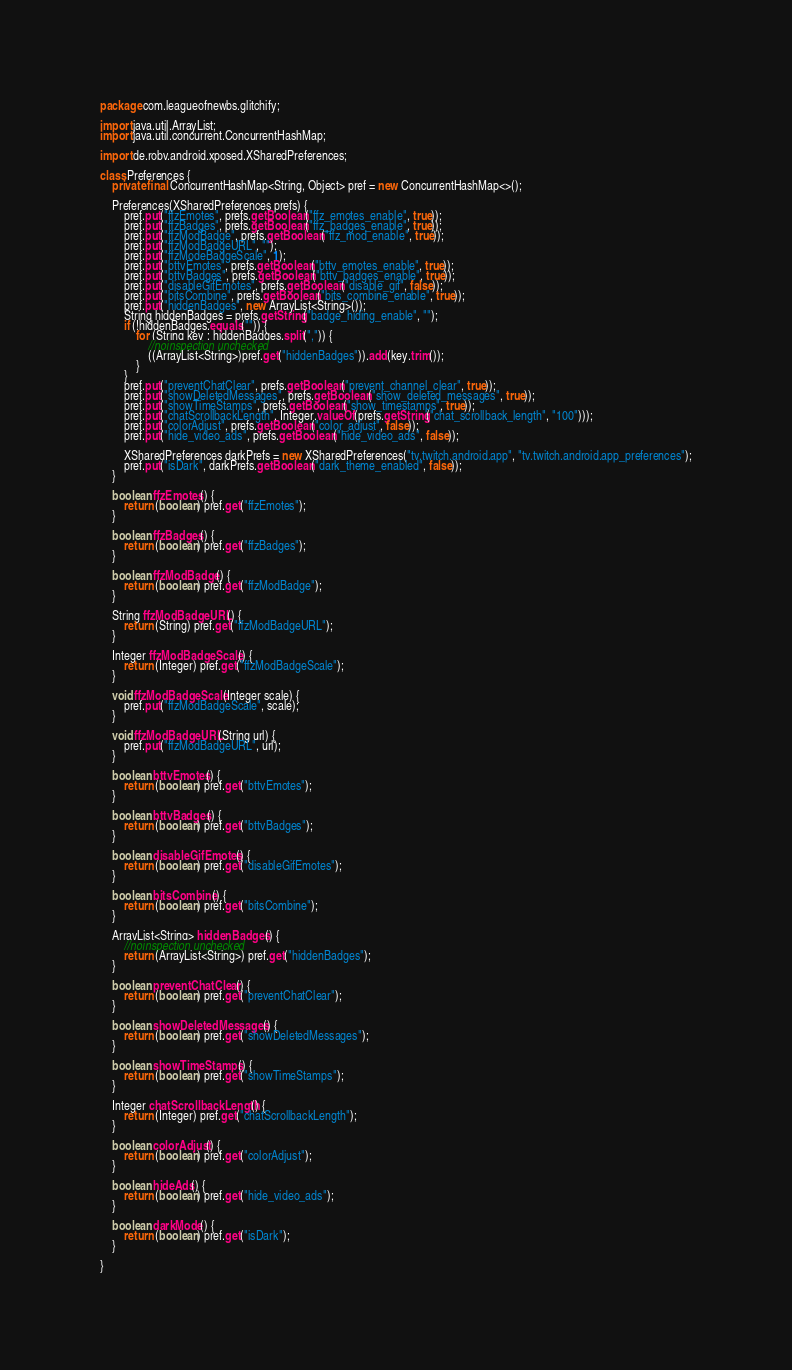Convert code to text. <code><loc_0><loc_0><loc_500><loc_500><_Java_>package com.leagueofnewbs.glitchify;

import java.util.ArrayList;
import java.util.concurrent.ConcurrentHashMap;

import de.robv.android.xposed.XSharedPreferences;

class Preferences {
    private final ConcurrentHashMap<String, Object> pref = new ConcurrentHashMap<>();

    Preferences(XSharedPreferences prefs) {
        pref.put("ffzEmotes", prefs.getBoolean("ffz_emotes_enable", true));
        pref.put("ffzBadges", prefs.getBoolean("ffz_badges_enable", true));
        pref.put("ffzModBadge", prefs.getBoolean("ffz_mod_enable", true));
        pref.put("ffzModBadgeURL", "");
        pref.put("ffzModeBadgeScale", 1);
        pref.put("bttvEmotes", prefs.getBoolean("bttv_emotes_enable", true));
        pref.put("bttvBadges", prefs.getBoolean("bttv_badges_enable", true));
        pref.put("disableGifEmotes", prefs.getBoolean("disable_gif", false));
        pref.put("bitsCombine", prefs.getBoolean("bits_combine_enable", true));
        pref.put("hiddenBadges", new ArrayList<String>());
        String hiddenBadges = prefs.getString("badge_hiding_enable", "");
        if (!hiddenBadges.equals("")) {
            for (String key : hiddenBadges.split(",")) {
                //noinspection unchecked
                ((ArrayList<String>)pref.get("hiddenBadges")).add(key.trim());
            }
        }
        pref.put("preventChatClear", prefs.getBoolean("prevent_channel_clear", true));
        pref.put("showDeletedMessages", prefs.getBoolean("show_deleted_messages", true));
        pref.put("showTimeStamps", prefs.getBoolean("show_timestamps", true));
        pref.put("chatScrollbackLength", Integer.valueOf(prefs.getString("chat_scrollback_length", "100")));
        pref.put("colorAdjust", prefs.getBoolean("color_adjust", false));
        pref.put("hide_video_ads", prefs.getBoolean("hide_video_ads", false));

        XSharedPreferences darkPrefs = new XSharedPreferences("tv.twitch.android.app", "tv.twitch.android.app_preferences");
        pref.put("isDark", darkPrefs.getBoolean("dark_theme_enabled", false));
    }

    boolean ffzEmotes() {
        return (boolean) pref.get("ffzEmotes");
    }

    boolean ffzBadges() {
        return (boolean) pref.get("ffzBadges");
    }

    boolean ffzModBadge() {
        return (boolean) pref.get("ffzModBadge");
    }

    String ffzModBadgeURL() {
        return (String) pref.get("ffzModBadgeURL");
    }

    Integer ffzModBadgeScale() {
        return (Integer) pref.get("ffzModBadgeScale");
    }

    void ffzModBadgeScale(Integer scale) {
        pref.put("ffzModBadgeScale", scale);
    }

    void ffzModBadgeURL(String url) {
        pref.put("ffzModBadgeURL", url);
    }

    boolean bttvEmotes() {
        return (boolean) pref.get("bttvEmotes");
    }

    boolean bttvBadges() {
        return (boolean) pref.get("bttvBadges");
    }

    boolean disableGifEmotes() {
        return (boolean) pref.get("disableGifEmotes");
    }

    boolean bitsCombine() {
        return (boolean) pref.get("bitsCombine");
    }

    ArrayList<String> hiddenBadges() {
        //noinspection unchecked
        return (ArrayList<String>) pref.get("hiddenBadges");
    }

    boolean preventChatClear() {
        return (boolean) pref.get("preventChatClear");
    }

    boolean showDeletedMessages() {
        return (boolean) pref.get("showDeletedMessages");
    }

    boolean showTimeStamps() {
        return (boolean) pref.get("showTimeStamps");
    }

    Integer chatScrollbackLength() {
        return (Integer) pref.get("chatScrollbackLength");
    }

    boolean colorAdjust() {
        return (boolean) pref.get("colorAdjust");
    }

    boolean hideAds() {
        return (boolean) pref.get("hide_video_ads");
    }

    boolean darkMode() {
        return (boolean) pref.get("isDark");
    }

}</code> 